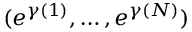<formula> <loc_0><loc_0><loc_500><loc_500>( e ^ { \gamma ( 1 ) } , \dots , e ^ { \gamma ( N ) } )</formula> 